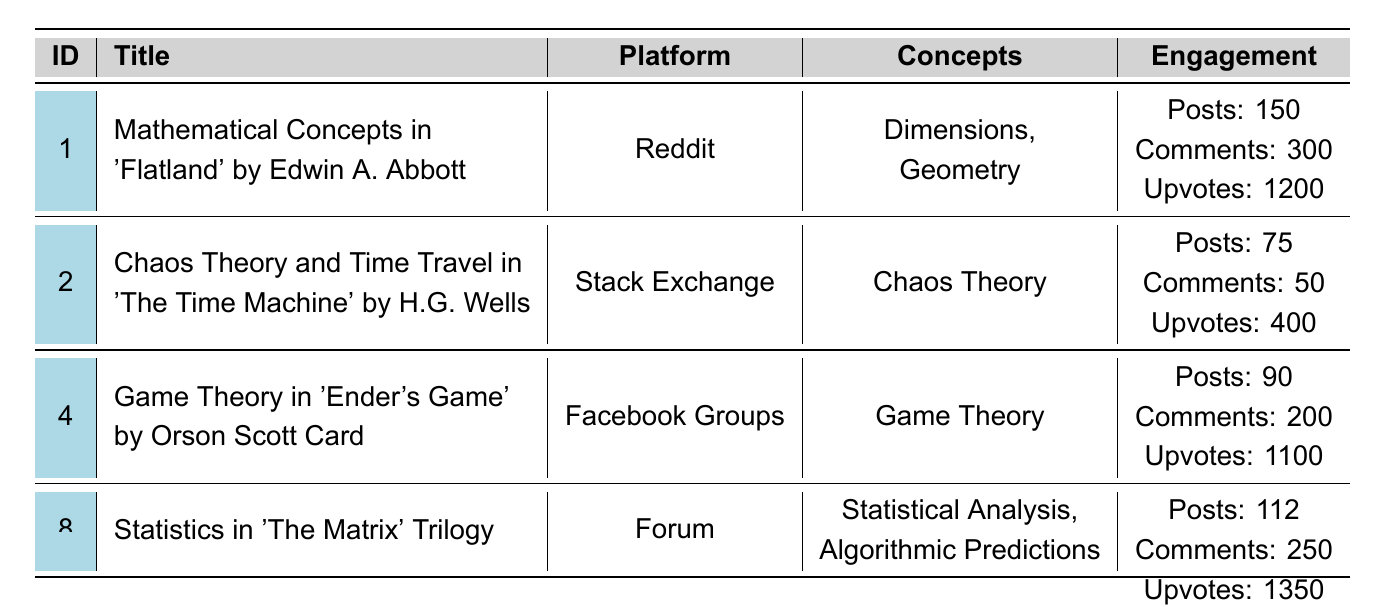What is the total number of posts across all discussions? We sum the number of posts from each discussion: 150 + 75 + 45 + 90 + 60 + 30 + 20 + 112 = 582 posts.
Answer: 582 posts Which discussion received the most upvotes? By checking the upvotes in each discussion, 'Statistics in The Matrix Trilogy' received the highest with 1350 upvotes.
Answer: 'Statistics in The Matrix Trilogy' How many discussions are focused on game theory? Reviewing the concepts for each discussion, only 'Game Theory in Ender's Game' mentions game theory. Therefore, there is 1 discussion focused on it.
Answer: 1 discussion What is the average number of comments for the discussions? We add the total number of comments: 300 + 50 + 120 + 200 + 80 + 90 + 40 + 250 = 1130 comments. There are 8 discussions, so the average is 1130 / 8 = 141.25.
Answer: 141.25 comments Did 'Chaos Theory and Time Travel in The Time Machine' receive more comments than 'Mathematical Concepts in Flatland'? The former received 50 comments, while the latter received 300 comments. Thus, 'Flatland' received more comments.
Answer: No Which platform has the highest total engagements (sum of posts, comments, and upvotes)? Calculate for each platform: Reddit (150 + 300 + 1200 = 1650), Stack Exchange (75 + 50 + 400 = 525), Facebook Groups (90 + 200 + 1100 = 1390), Forum (112 + 250 + 1350 = 1712). Forum has the highest engagement total.
Answer: Forum What concept was discussed in the least engaged discussion? The least engagement is from 'Quantum Computing in Neuromancer' with 20 posts, 40 comments, and 250 upvotes totaling 310.
Answer: 'Quantum Computing in Neuromancer' How many discussions mention more than one mathematical concept? The discussions with multiple concepts are 'Mathematical Concepts in Flatland', 'Statistics in The Matrix Trilogy', and 'Chaos Theory and Time Travel in The Time Machine', totaling 3 discussions.
Answer: 3 discussions Which discussion had the highest number of comments in relation to the number of posts? Calculate the ratio of comments to posts for each: Flatland (300/150=2), Time Machine (50/75=0.67), Ender's Game (200/90=2.22), and Matrix (250/112=2.23). The Matrix had the highest ratio.
Answer: 'Statistics in The Matrix Trilogy' Was the discussion about fractals and nature more engaging than the one on quantum computing? Total engagement for fractals and nature is 60 + 80 + 600 = 740, while for quantum computing it is 20 + 40 + 250 = 310. Thus, the former is more engaging.
Answer: Yes How many unique mathematical concepts are discussed across all entries? The unique concepts are Dimensions, Geometry, Chaos Theory, Nonlinear Dynamics, Probability, Multiverse Theory, Game Theory, Strategic Thinking, Fractals, Geometric Patterns, Logic, Linguistics, Quantum Physics, Computational Theory, Statistical Analysis, and Algorithmic Predictions, totaling 16 unique concepts.
Answer: 16 unique concepts 